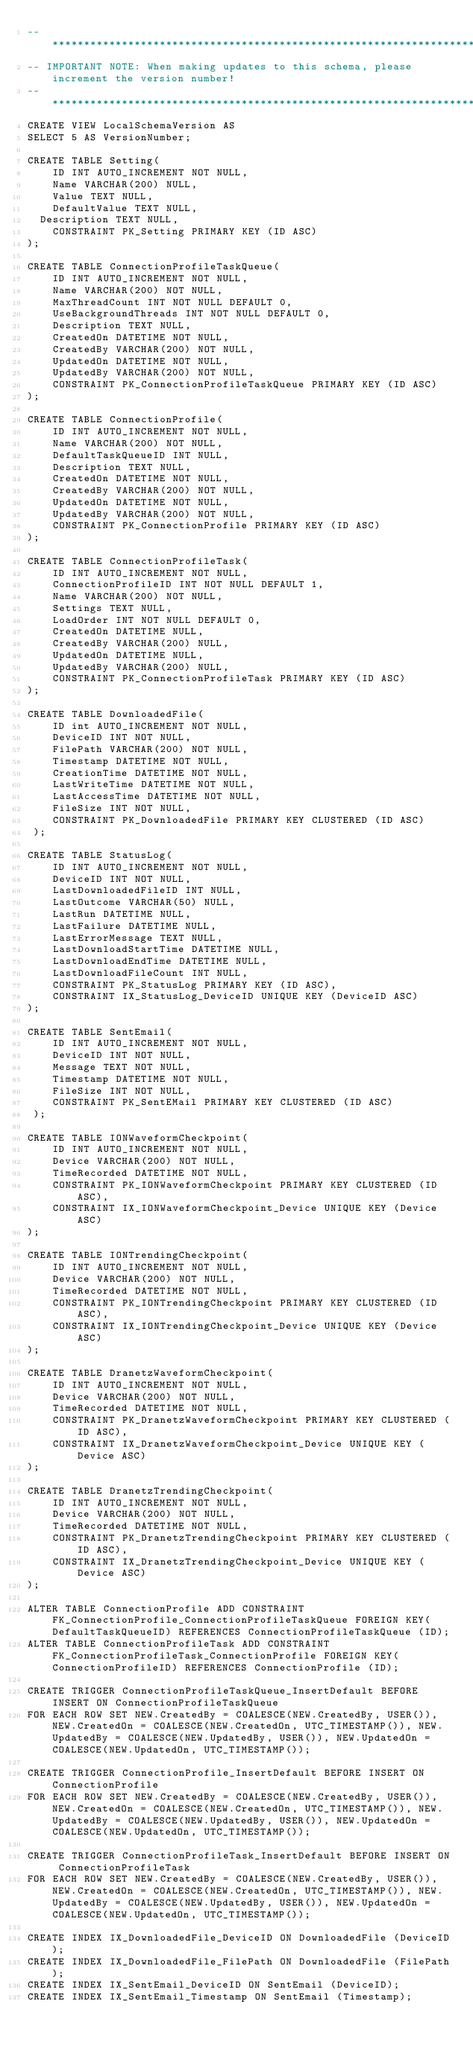<code> <loc_0><loc_0><loc_500><loc_500><_SQL_>-- *******************************************************************************************
-- IMPORTANT NOTE: When making updates to this schema, please increment the version number!
-- *******************************************************************************************
CREATE VIEW LocalSchemaVersion AS
SELECT 5 AS VersionNumber;

CREATE TABLE Setting(
    ID INT AUTO_INCREMENT NOT NULL,
    Name VARCHAR(200) NULL,
    Value TEXT NULL,
    DefaultValue TEXT NULL,
	Description TEXT NULL,
    CONSTRAINT PK_Setting PRIMARY KEY (ID ASC)
);

CREATE TABLE ConnectionProfileTaskQueue(
    ID INT AUTO_INCREMENT NOT NULL,
    Name VARCHAR(200) NOT NULL,
    MaxThreadCount INT NOT NULL DEFAULT 0,
    UseBackgroundThreads INT NOT NULL DEFAULT 0,
    Description TEXT NULL,
    CreatedOn DATETIME NOT NULL,
    CreatedBy VARCHAR(200) NOT NULL,
    UpdatedOn DATETIME NOT NULL,
    UpdatedBy VARCHAR(200) NOT NULL,
    CONSTRAINT PK_ConnectionProfileTaskQueue PRIMARY KEY (ID ASC)
);

CREATE TABLE ConnectionProfile(
    ID INT AUTO_INCREMENT NOT NULL,
    Name VARCHAR(200) NOT NULL,
    DefaultTaskQueueID INT NULL,
    Description TEXT NULL,
    CreatedOn DATETIME NOT NULL,
    CreatedBy VARCHAR(200) NOT NULL,
    UpdatedOn DATETIME NOT NULL,
    UpdatedBy VARCHAR(200) NOT NULL,
    CONSTRAINT PK_ConnectionProfile PRIMARY KEY (ID ASC)
);

CREATE TABLE ConnectionProfileTask(
    ID INT AUTO_INCREMENT NOT NULL,
    ConnectionProfileID INT NOT NULL DEFAULT 1,
    Name VARCHAR(200) NOT NULL,
    Settings TEXT NULL,
    LoadOrder INT NOT NULL DEFAULT 0,
    CreatedOn DATETIME NULL,
    CreatedBy VARCHAR(200) NULL,
    UpdatedOn DATETIME NULL,
    UpdatedBy VARCHAR(200) NULL,
    CONSTRAINT PK_ConnectionProfileTask PRIMARY KEY (ID ASC)
);

CREATE TABLE DownloadedFile(
    ID int AUTO_INCREMENT NOT NULL,
    DeviceID INT NOT NULL,
    FilePath VARCHAR(200) NOT NULL,
    Timestamp DATETIME NOT NULL,
    CreationTime DATETIME NOT NULL,
    LastWriteTime DATETIME NOT NULL,
    LastAccessTime DATETIME NOT NULL,
    FileSize INT NOT NULL,
    CONSTRAINT PK_DownloadedFile PRIMARY KEY CLUSTERED (ID ASC)
 );

CREATE TABLE StatusLog(
    ID INT AUTO_INCREMENT NOT NULL,
    DeviceID INT NOT NULL,
    LastDownloadedFileID INT NULL,
    LastOutcome VARCHAR(50) NULL,
    LastRun DATETIME NULL,
    LastFailure DATETIME NULL,
    LastErrorMessage TEXT NULL,
    LastDownloadStartTime DATETIME NULL,
    LastDownloadEndTime DATETIME NULL,
    LastDownloadFileCount INT NULL,
    CONSTRAINT PK_StatusLog PRIMARY KEY (ID ASC),
    CONSTRAINT IX_StatusLog_DeviceID UNIQUE KEY (DeviceID ASC)
);

CREATE TABLE SentEmail(
    ID INT AUTO_INCREMENT NOT NULL,
    DeviceID INT NOT NULL,
    Message TEXT NOT NULL,
    Timestamp DATETIME NOT NULL,
    FileSize INT NOT NULL,
    CONSTRAINT PK_SentEMail PRIMARY KEY CLUSTERED (ID ASC) 
 );

CREATE TABLE IONWaveformCheckpoint(
    ID INT AUTO_INCREMENT NOT NULL,
    Device VARCHAR(200) NOT NULL,
    TimeRecorded DATETIME NOT NULL,
    CONSTRAINT PK_IONWaveformCheckpoint PRIMARY KEY CLUSTERED (ID ASC),
    CONSTRAINT IX_IONWaveformCheckpoint_Device UNIQUE KEY (Device ASC)
);

CREATE TABLE IONTrendingCheckpoint(
    ID INT AUTO_INCREMENT NOT NULL,
    Device VARCHAR(200) NOT NULL,
    TimeRecorded DATETIME NOT NULL,
    CONSTRAINT PK_IONTrendingCheckpoint PRIMARY KEY CLUSTERED (ID ASC),
    CONSTRAINT IX_IONTrendingCheckpoint_Device UNIQUE KEY (Device ASC)
);

CREATE TABLE DranetzWaveformCheckpoint(
    ID INT AUTO_INCREMENT NOT NULL,
    Device VARCHAR(200) NOT NULL,
    TimeRecorded DATETIME NOT NULL,
    CONSTRAINT PK_DranetzWaveformCheckpoint PRIMARY KEY CLUSTERED (ID ASC),
    CONSTRAINT IX_DranetzWaveformCheckpoint_Device UNIQUE KEY (Device ASC)
);

CREATE TABLE DranetzTrendingCheckpoint(
    ID INT AUTO_INCREMENT NOT NULL,
    Device VARCHAR(200) NOT NULL,
    TimeRecorded DATETIME NOT NULL,
    CONSTRAINT PK_DranetzTrendingCheckpoint PRIMARY KEY CLUSTERED (ID ASC),
    CONSTRAINT IX_DranetzTrendingCheckpoint_Device UNIQUE KEY (Device ASC)
);

ALTER TABLE ConnectionProfile ADD CONSTRAINT FK_ConnectionProfile_ConnectionProfileTaskQueue FOREIGN KEY(DefaultTaskQueueID) REFERENCES ConnectionProfileTaskQueue (ID);
ALTER TABLE ConnectionProfileTask ADD CONSTRAINT FK_ConnectionProfileTask_ConnectionProfile FOREIGN KEY(ConnectionProfileID) REFERENCES ConnectionProfile (ID);

CREATE TRIGGER ConnectionProfileTaskQueue_InsertDefault BEFORE INSERT ON ConnectionProfileTaskQueue
FOR EACH ROW SET NEW.CreatedBy = COALESCE(NEW.CreatedBy, USER()), NEW.CreatedOn = COALESCE(NEW.CreatedOn, UTC_TIMESTAMP()), NEW.UpdatedBy = COALESCE(NEW.UpdatedBy, USER()), NEW.UpdatedOn = COALESCE(NEW.UpdatedOn, UTC_TIMESTAMP());

CREATE TRIGGER ConnectionProfile_InsertDefault BEFORE INSERT ON ConnectionProfile
FOR EACH ROW SET NEW.CreatedBy = COALESCE(NEW.CreatedBy, USER()), NEW.CreatedOn = COALESCE(NEW.CreatedOn, UTC_TIMESTAMP()), NEW.UpdatedBy = COALESCE(NEW.UpdatedBy, USER()), NEW.UpdatedOn = COALESCE(NEW.UpdatedOn, UTC_TIMESTAMP());

CREATE TRIGGER ConnectionProfileTask_InsertDefault BEFORE INSERT ON ConnectionProfileTask
FOR EACH ROW SET NEW.CreatedBy = COALESCE(NEW.CreatedBy, USER()), NEW.CreatedOn = COALESCE(NEW.CreatedOn, UTC_TIMESTAMP()), NEW.UpdatedBy = COALESCE(NEW.UpdatedBy, USER()), NEW.UpdatedOn = COALESCE(NEW.UpdatedOn, UTC_TIMESTAMP());

CREATE INDEX IX_DownloadedFile_DeviceID ON DownloadedFile (DeviceID);
CREATE INDEX IX_DownloadedFile_FilePath ON DownloadedFile (FilePath);
CREATE INDEX IX_SentEmail_DeviceID ON SentEmail (DeviceID);
CREATE INDEX IX_SentEmail_Timestamp ON SentEmail (Timestamp);
</code> 